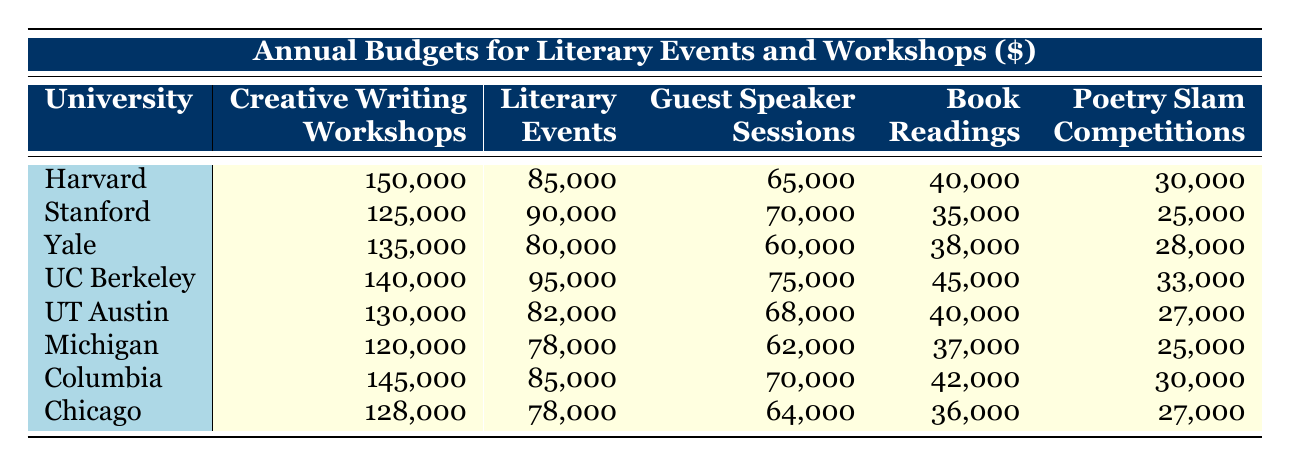What is the highest budget for Creative Writing Workshops? According to the table, Harvard University has the highest budget for Creative Writing Workshops at 150,000.
Answer: 150,000 Which university has the lowest budget for Poetry Slam Competitions? The university with the lowest budget for Poetry Slam Competitions is the University of Texas at Austin, which has a budget of 27,000.
Answer: 27,000 What is the total budget for Literary Events across all universities? To find the total budget for Literary Events, we need to sum the budgets: 85,000 + 90,000 + 80,000 + 95,000 + 82,000 + 78,000 + 85,000 + 78,000 = 788,000.
Answer: 788,000 Which university allocates more budget for Book Readings: Stanford University or Yale University? Stanford University has a budget of 35,000 for Book Readings, while Yale University has 38,000. Since 38,000 is greater than 35,000, Yale University allocates more.
Answer: Yale University What is the average budget for Guest Speaker Sessions among the listed universities? The total budget for Guest Speaker Sessions is 65,000 + 70,000 + 60,000 + 75,000 + 68,000 + 62,000 + 70,000 + 64,000 = 564,000. There are 8 universities, so the average is 564,000 / 8 = 70,500.
Answer: 70,500 Is it true that UC Berkeley spends less on Literary Events than Yale University? UC Berkeley has a budget of 95,000 for Literary Events while Yale University has 80,000. Since 95,000 is greater than 80,000, the statement is false.
Answer: False Which university spends a higher amount on both Guest Speaker Sessions and Book Readings: Columbia University or the University of Chicago? Columbia University has 70,000 for Guest Speaker Sessions and 42,000 for Book Readings, totaling 112,000. The University of Chicago has 64,000 for Guest Speaker Sessions and 36,000 for Book Readings, totaling 100,000. Since 112,000 is greater than 100,000, Columbia University spends more overall on these two categories.
Answer: Columbia University How much more does Harvard University spend on Creative Writing Workshops compared to the University of Michigan? Harvard University spends 150,000 on Creative Writing Workshops while the University of Michigan spends 120,000. The difference is 150,000 - 120,000 = 30,000.
Answer: 30,000 